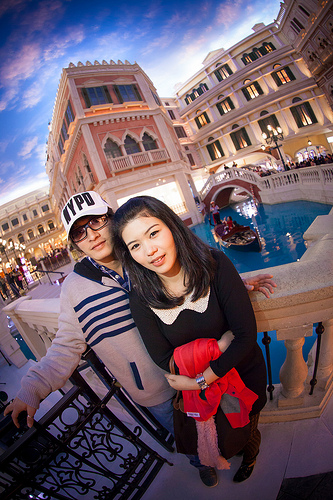<image>
Is there a cap on the woman? No. The cap is not positioned on the woman. They may be near each other, but the cap is not supported by or resting on top of the woman. Is the hat on the woman? No. The hat is not positioned on the woman. They may be near each other, but the hat is not supported by or resting on top of the woman. Is there a cap on the girl? No. The cap is not positioned on the girl. They may be near each other, but the cap is not supported by or resting on top of the girl. 